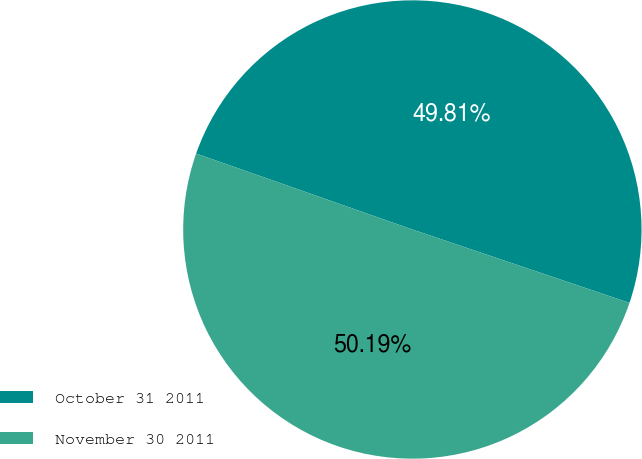Convert chart. <chart><loc_0><loc_0><loc_500><loc_500><pie_chart><fcel>October 31 2011<fcel>November 30 2011<nl><fcel>49.81%<fcel>50.19%<nl></chart> 